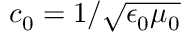<formula> <loc_0><loc_0><loc_500><loc_500>c _ { 0 } = 1 / \sqrt { \epsilon _ { 0 } \mu _ { 0 } }</formula> 